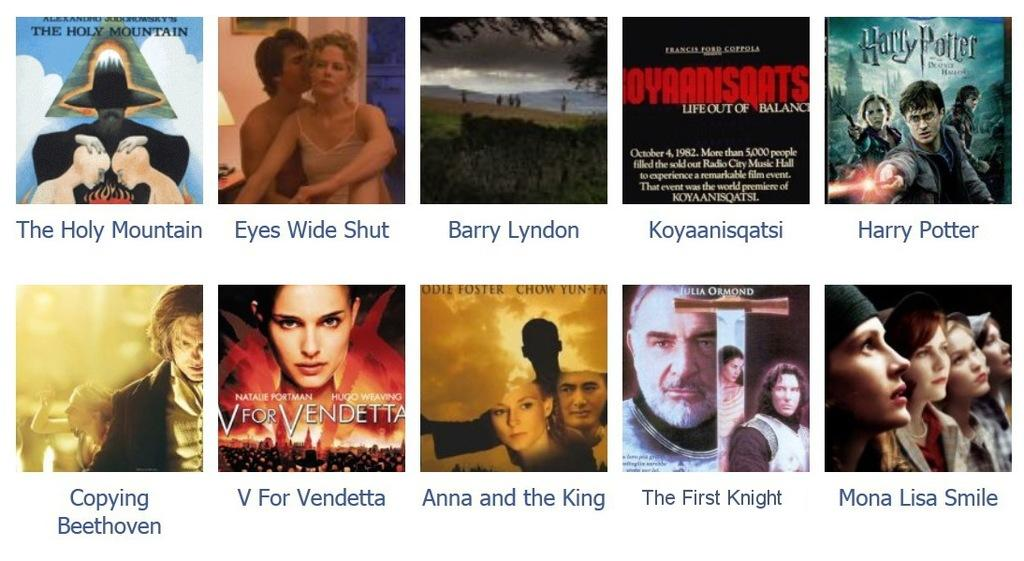How many book covers can be seen in the image? There are ten images in the picture, and each looks like a front cover of a book. What is depicted on some of the book covers? Groups of people and trees are present in some of the images, while mountains are depicted in others. Is there any text visible on the book covers? Yes, text is visible on the book covers. What else can be seen in the background of some of the images? The sky is visible in some of the images. How many horses are depicted in the image? There are no horses present in the image; the images depict book covers with various subjects, including groups of people and natural landscapes. What is the governor's role in the image? There is no governor depicted in the image, as it consists of book covers with different subjects and themes. 